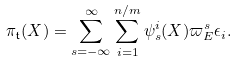<formula> <loc_0><loc_0><loc_500><loc_500>\pi _ { \mathfrak { t } } ( X ) = \sum _ { s = - \infty } ^ { \infty } \sum _ { i = 1 } ^ { n / m } \psi _ { s } ^ { i } ( X ) \varpi _ { E } ^ { s } \epsilon _ { i } .</formula> 